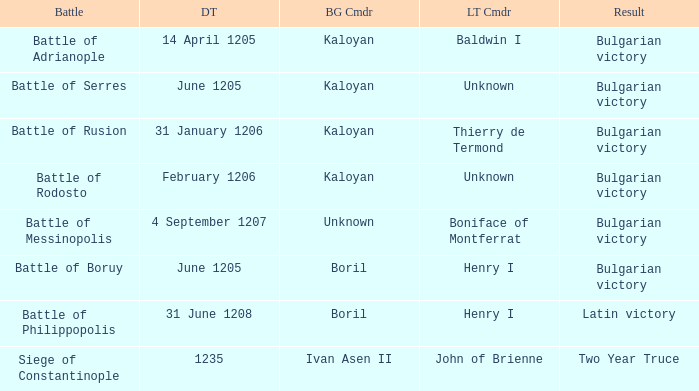What is the Battle with Bulgarian Commander Ivan Asen II? Siege of Constantinople. 